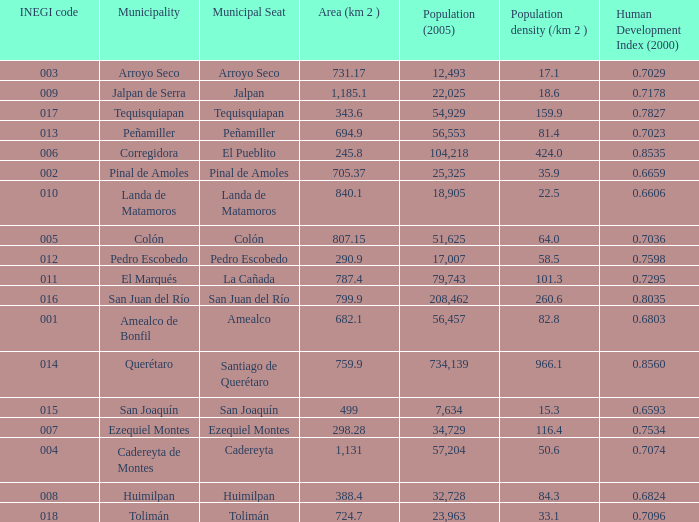WHat is the amount of Human Development Index (2000) that has a Population (2005) of 54,929, and an Area (km 2 ) larger than 343.6? 0.0. 